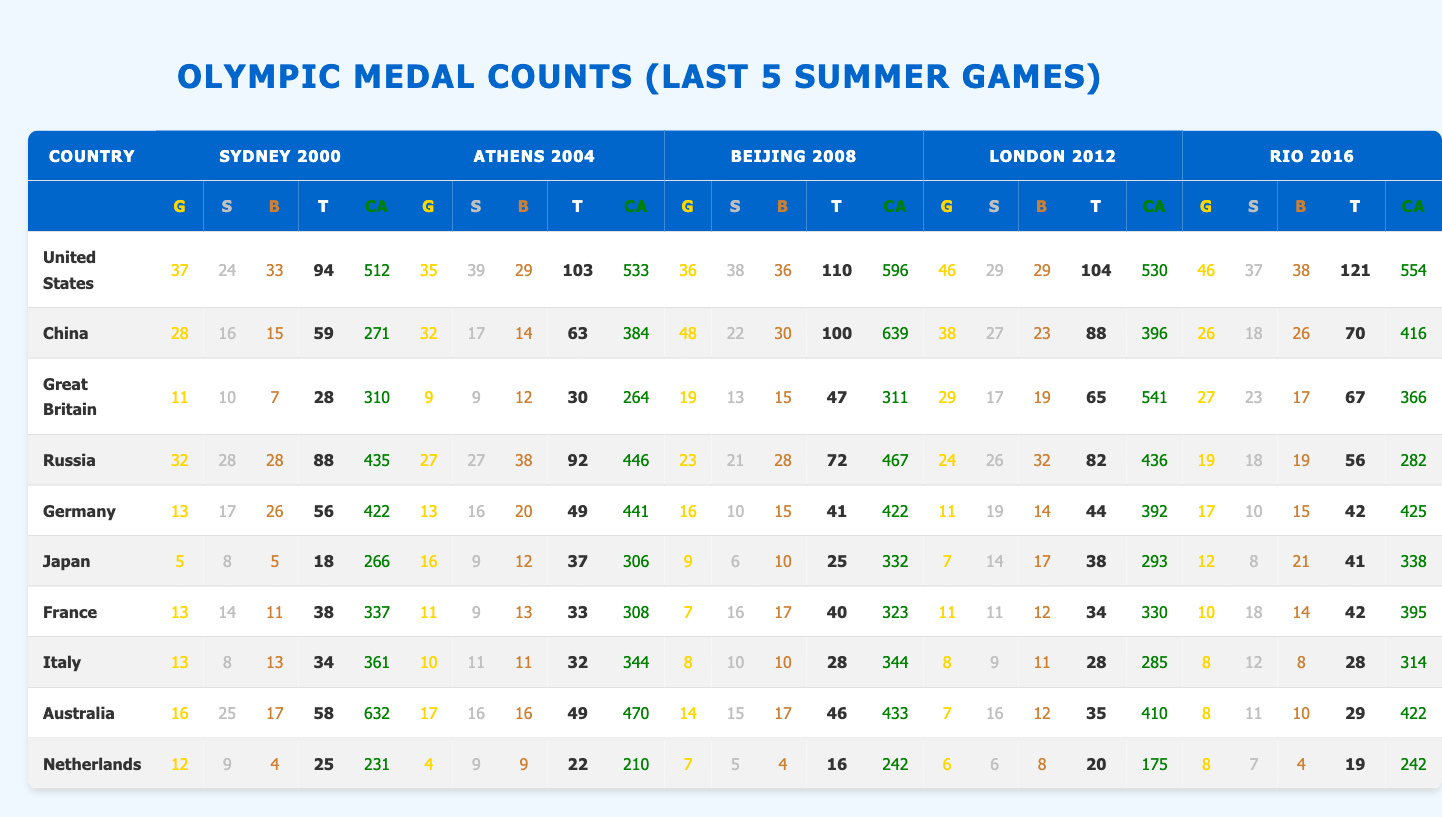What country won the most gold medals in the 2016 Rio Games? The table shows that the United States won 46 gold medals in the 2016 Rio Games, which is the highest number among all countries listed.
Answer: United States Which country had the highest total medal count in the 2008 Beijing Games? In the 2008 Beijing Games, the United States had the highest total medal count with 110 medals, compared to other countries.
Answer: United States How many total medals did China win in the 2004 Athens Games? The table indicates that China won a total of 63 medals (32 gold, 17 silver, 14 bronze) in the 2004 Athens Games.
Answer: 63 Which country won the fewest medals in the 2012 London Games? The table reveals that the Netherlands won the fewest medals with a total of 20 in the 2012 London Games.
Answer: Netherlands What was the average number of clean athletes for the United States across all Games? To find the average, add the clean athletes from each Games for the United States: 512 (2000) + 533 (2004) + 596 (2008) + 530 (2012) + 554 (2016) = 2731. Then divide by 5: 2731 / 5 = 546.2.
Answer: 546.2 How did Japan's total medal count in the London Games compare to their count in the Rio Games? Japan had 38 medals in the London Games and 41 medals in the Rio Games, indicating an increase of 3 medals in the latter.
Answer: Increased by 3 Did any country have a higher total count in 2000 than in 2004? The total medal counts for 2000 and 2004 are compared: United States (94 vs 103), China (59 vs 63), Great Britain (28 vs 30), Russia (88 vs 92), Germany (56 vs 49), Japan (18 vs 37), France (38 vs 33), Italy (34 vs 32), Australia (58 vs 49), Netherlands (25 vs 22). The comparison shows that none had a higher count in 2004 than in 2000; all countries except Russia can be concluded to have lower medals in 2004.
Answer: No What was the increase in total medals for Germany from the 2008 Beijing to the 2012 London Games? Germany won 41 medals in 2008 and 44 medals in 2012. The increase can be calculated as 44 - 41 = 3.
Answer: 3 Which country had the most consistent medal performance across the last 5 Games based on total counts? By examining the total counts over the five games, the United States consistently had high totals (94, 103, 110, 104, 121), whereas other countries like Japan and Germany exhibited more fluctuations.
Answer: United States What percentage of total medals in the 2016 Rio Games did the United States win? The total medals in the 2016 Rio Games is 321. The United States won 121, which is 121/321 * 100 = 37.7%.
Answer: 37.7% 